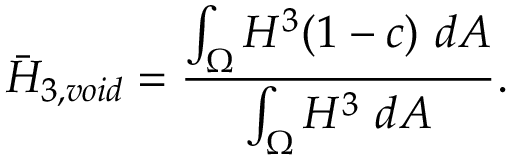<formula> <loc_0><loc_0><loc_500><loc_500>\bar { H } _ { 3 , v o i d } = \frac { \int _ { \Omega } H ^ { 3 } ( 1 - c ) d A } { \int _ { \Omega } H ^ { 3 } d A } .</formula> 